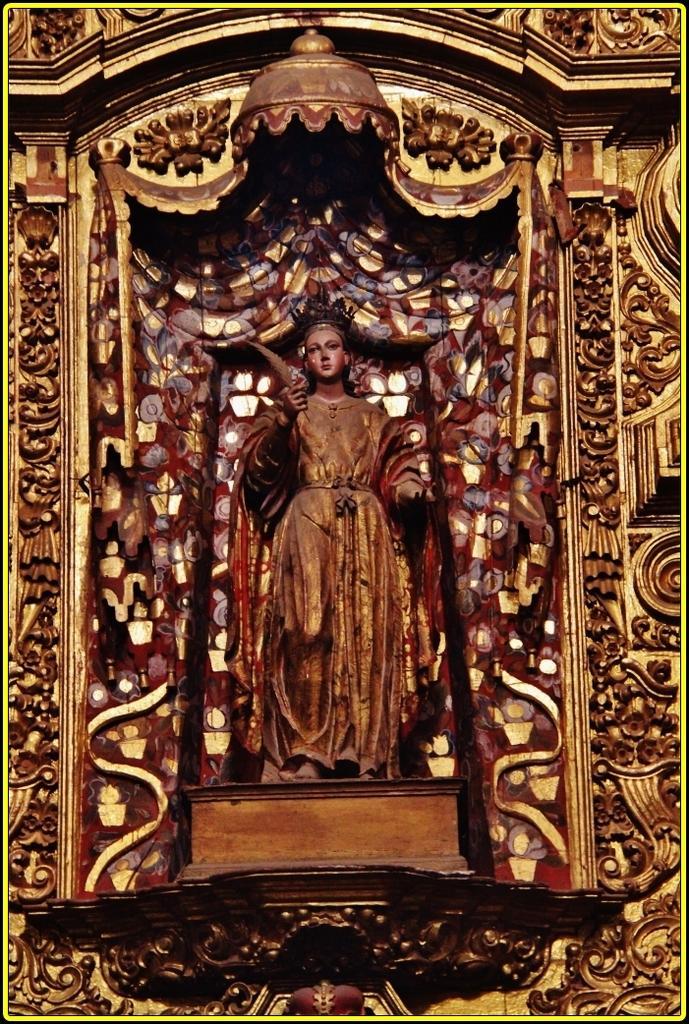Can you describe this image briefly? This image is consists of a sculpture in the image. 